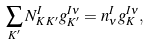<formula> <loc_0><loc_0><loc_500><loc_500>\sum _ { K ^ { \prime } } N _ { K \, K ^ { \prime } } ^ { I } g _ { K ^ { \prime } } ^ { I \nu } = n _ { \nu } ^ { I } g _ { K } ^ { I \nu } ,</formula> 